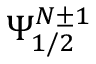<formula> <loc_0><loc_0><loc_500><loc_500>\Psi _ { 1 / 2 } ^ { N \pm 1 }</formula> 